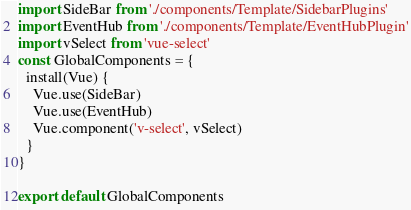Convert code to text. <code><loc_0><loc_0><loc_500><loc_500><_JavaScript_>import SideBar from './components/Template/SidebarPlugins'
import EventHub from './components/Template/EventHubPlugin'
import vSelect from 'vue-select'
const GlobalComponents = {
  install(Vue) {
    Vue.use(SideBar)
    Vue.use(EventHub)
    Vue.component('v-select', vSelect)
  }
}

export default GlobalComponents</code> 